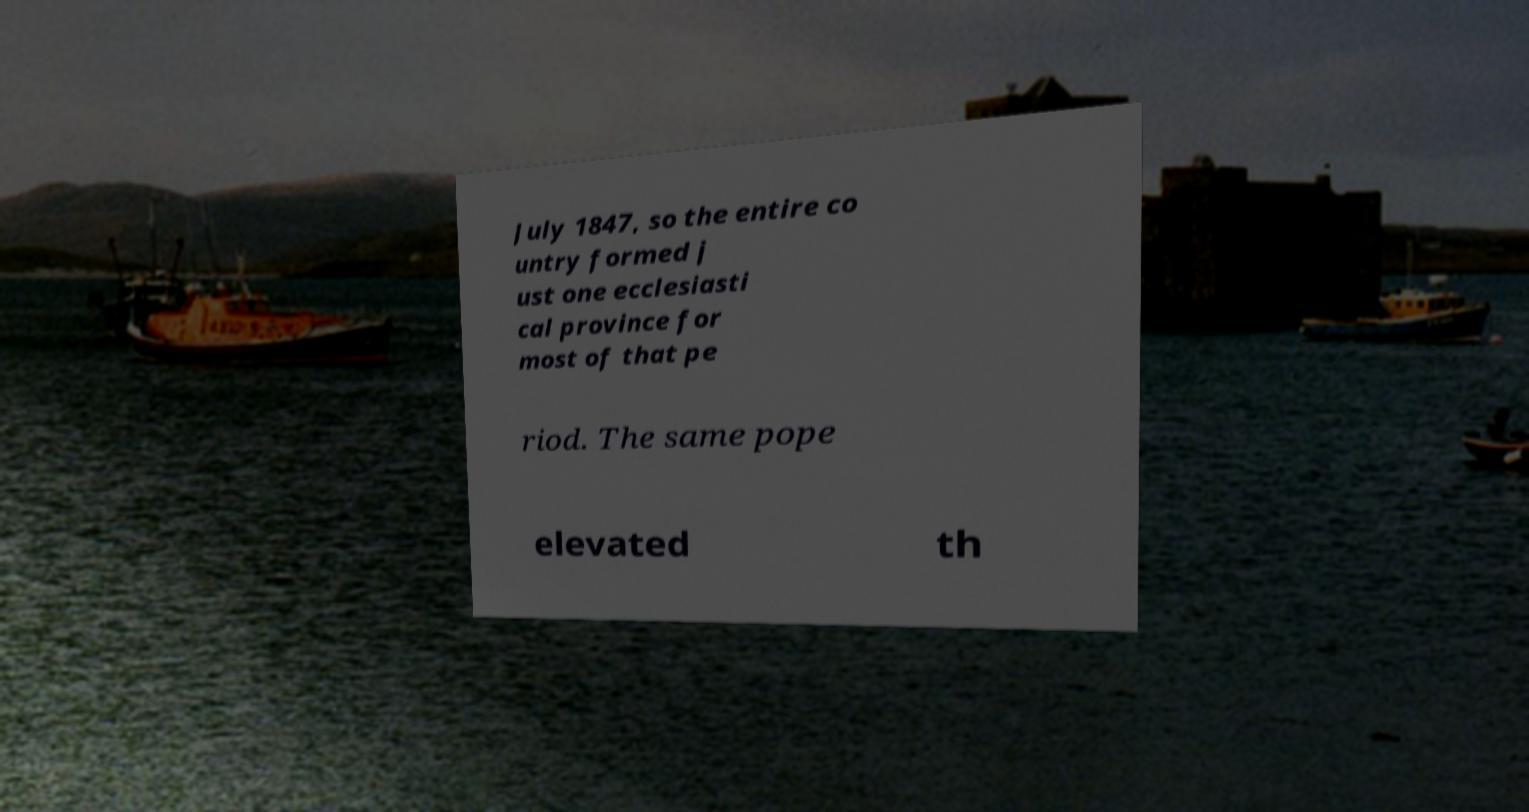Could you extract and type out the text from this image? July 1847, so the entire co untry formed j ust one ecclesiasti cal province for most of that pe riod. The same pope elevated th 